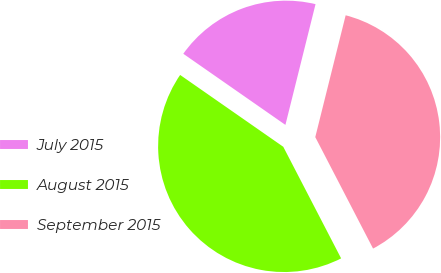<chart> <loc_0><loc_0><loc_500><loc_500><pie_chart><fcel>July 2015<fcel>August 2015<fcel>September 2015<nl><fcel>19.21%<fcel>42.3%<fcel>38.5%<nl></chart> 